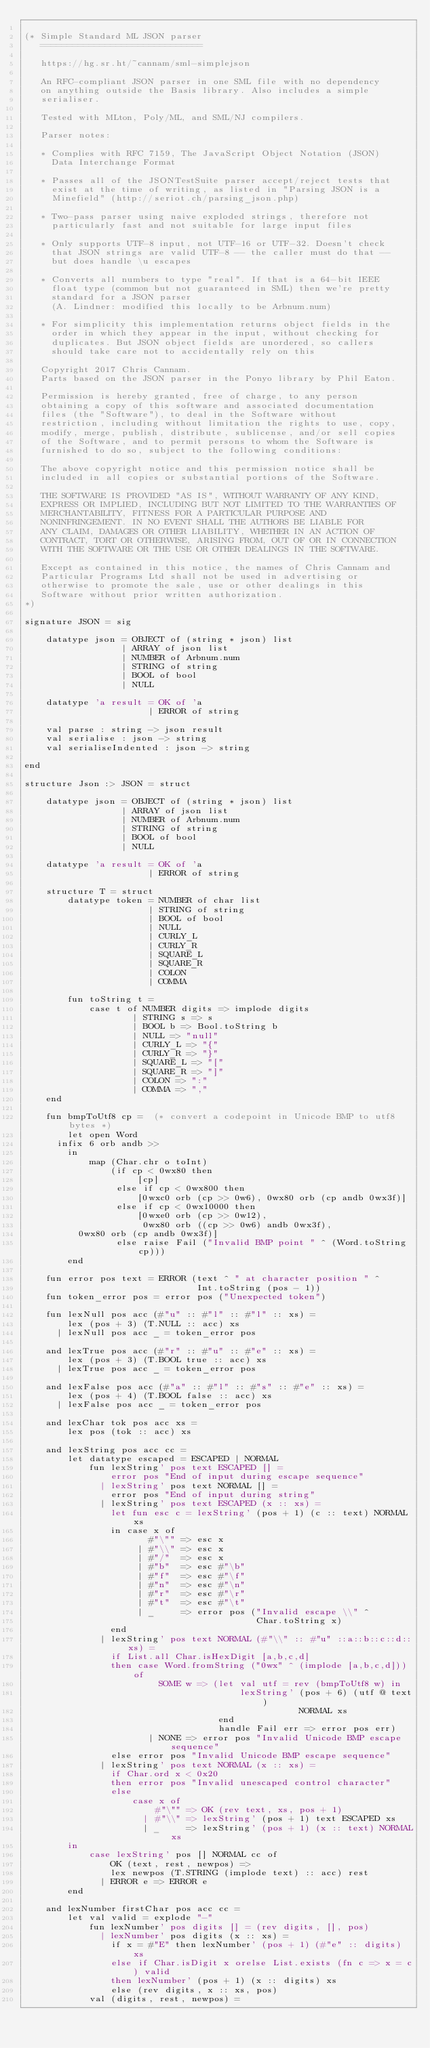<code> <loc_0><loc_0><loc_500><loc_500><_SML_>
(* Simple Standard ML JSON parser
   ==============================

   https://hg.sr.ht/~cannam/sml-simplejson

   An RFC-compliant JSON parser in one SML file with no dependency 
   on anything outside the Basis library. Also includes a simple
   serialiser.

   Tested with MLton, Poly/ML, and SML/NJ compilers.

   Parser notes:

   * Complies with RFC 7159, The JavaScript Object Notation (JSON)
     Data Interchange Format

   * Passes all of the JSONTestSuite parser accept/reject tests that
     exist at the time of writing, as listed in "Parsing JSON is a
     Minefield" (http://seriot.ch/parsing_json.php)
 
   * Two-pass parser using naive exploded strings, therefore not
     particularly fast and not suitable for large input files

   * Only supports UTF-8 input, not UTF-16 or UTF-32. Doesn't check
     that JSON strings are valid UTF-8 -- the caller must do that --
     but does handle \u escapes

   * Converts all numbers to type "real". If that is a 64-bit IEEE
     float type (common but not guaranteed in SML) then we're pretty
     standard for a JSON parser
     (A. Lindner: modified this locally to be Arbnum.num)

   * For simplicity this implementation returns object fields in the
     order in which they appear in the input, without checking for
     duplicates. But JSON object fields are unordered, so callers
     should take care not to accidentally rely on this

   Copyright 2017 Chris Cannam.
   Parts based on the JSON parser in the Ponyo library by Phil Eaton.

   Permission is hereby granted, free of charge, to any person
   obtaining a copy of this software and associated documentation
   files (the "Software"), to deal in the Software without
   restriction, including without limitation the rights to use, copy,
   modify, merge, publish, distribute, sublicense, and/or sell copies
   of the Software, and to permit persons to whom the Software is
   furnished to do so, subject to the following conditions:

   The above copyright notice and this permission notice shall be
   included in all copies or substantial portions of the Software.

   THE SOFTWARE IS PROVIDED "AS IS", WITHOUT WARRANTY OF ANY KIND,
   EXPRESS OR IMPLIED, INCLUDING BUT NOT LIMITED TO THE WARRANTIES OF
   MERCHANTABILITY, FITNESS FOR A PARTICULAR PURPOSE AND
   NONINFRINGEMENT. IN NO EVENT SHALL THE AUTHORS BE LIABLE FOR
   ANY CLAIM, DAMAGES OR OTHER LIABILITY, WHETHER IN AN ACTION OF
   CONTRACT, TORT OR OTHERWISE, ARISING FROM, OUT OF OR IN CONNECTION
   WITH THE SOFTWARE OR THE USE OR OTHER DEALINGS IN THE SOFTWARE.

   Except as contained in this notice, the names of Chris Cannam and
   Particular Programs Ltd shall not be used in advertising or
   otherwise to promote the sale, use or other dealings in this
   Software without prior written authorization.
*)

signature JSON = sig

    datatype json = OBJECT of (string * json) list
                  | ARRAY of json list
                  | NUMBER of Arbnum.num
                  | STRING of string
                  | BOOL of bool
                  | NULL

    datatype 'a result = OK of 'a
                       | ERROR of string

    val parse : string -> json result
    val serialise : json -> string
    val serialiseIndented : json -> string

end

structure Json :> JSON = struct

    datatype json = OBJECT of (string * json) list
                  | ARRAY of json list
                  | NUMBER of Arbnum.num
                  | STRING of string
                  | BOOL of bool
                  | NULL

    datatype 'a result = OK of 'a
                       | ERROR of string

    structure T = struct
        datatype token = NUMBER of char list
                       | STRING of string
                       | BOOL of bool
                       | NULL
                       | CURLY_L
                       | CURLY_R
                       | SQUARE_L
                       | SQUARE_R
                       | COLON
                       | COMMA

        fun toString t =
            case t of NUMBER digits => implode digits
                    | STRING s => s
                    | BOOL b => Bool.toString b
                    | NULL => "null"
                    | CURLY_L => "{"
                    | CURLY_R => "}"
                    | SQUARE_L => "["
                    | SQUARE_R => "]"
                    | COLON => ":"
                    | COMMA => ","
    end

    fun bmpToUtf8 cp =  (* convert a codepoint in Unicode BMP to utf8 bytes *)
        let open Word
	    infix 6 orb andb >>
        in
            map (Char.chr o toInt)
                (if cp < 0wx80 then
                     [cp]
                 else if cp < 0wx800 then
                     [0wxc0 orb (cp >> 0w6), 0wx80 orb (cp andb 0wx3f)]
                 else if cp < 0wx10000 then
                     [0wxe0 orb (cp >> 0w12),
                      0wx80 orb ((cp >> 0w6) andb 0wx3f),
		      0wx80 orb (cp andb 0wx3f)]
                 else raise Fail ("Invalid BMP point " ^ (Word.toString cp)))
        end
                      
    fun error pos text = ERROR (text ^ " at character position " ^
                                Int.toString (pos - 1))
    fun token_error pos = error pos ("Unexpected token")

    fun lexNull pos acc (#"u" :: #"l" :: #"l" :: xs) =
        lex (pos + 3) (T.NULL :: acc) xs
      | lexNull pos acc _ = token_error pos

    and lexTrue pos acc (#"r" :: #"u" :: #"e" :: xs) =
        lex (pos + 3) (T.BOOL true :: acc) xs
      | lexTrue pos acc _ = token_error pos

    and lexFalse pos acc (#"a" :: #"l" :: #"s" :: #"e" :: xs) =
        lex (pos + 4) (T.BOOL false :: acc) xs
      | lexFalse pos acc _ = token_error pos

    and lexChar tok pos acc xs =
        lex pos (tok :: acc) xs
        
    and lexString pos acc cc =
        let datatype escaped = ESCAPED | NORMAL
            fun lexString' pos text ESCAPED [] =
                error pos "End of input during escape sequence"
              | lexString' pos text NORMAL [] = 
                error pos "End of input during string"
              | lexString' pos text ESCAPED (x :: xs) =
                let fun esc c = lexString' (pos + 1) (c :: text) NORMAL xs
                in case x of
                       #"\"" => esc x
                     | #"\\" => esc x
                     | #"/"  => esc x
                     | #"b"  => esc #"\b"
                     | #"f"  => esc #"\f"
                     | #"n"  => esc #"\n"
                     | #"r"  => esc #"\r"
                     | #"t"  => esc #"\t"
                     | _     => error pos ("Invalid escape \\" ^
                                           Char.toString x)
                end
              | lexString' pos text NORMAL (#"\\" :: #"u" ::a::b::c::d:: xs) =
                if List.all Char.isHexDigit [a,b,c,d]
                then case Word.fromString ("0wx" ^ (implode [a,b,c,d])) of
                         SOME w => (let val utf = rev (bmpToUtf8 w) in
                                        lexString' (pos + 6) (utf @ text)
                                                   NORMAL xs
                                    end
                                    handle Fail err => error pos err)
                       | NONE => error pos "Invalid Unicode BMP escape sequence"
                else error pos "Invalid Unicode BMP escape sequence"
              | lexString' pos text NORMAL (x :: xs) =
                if Char.ord x < 0x20
                then error pos "Invalid unescaped control character"
                else
                    case x of
                        #"\"" => OK (rev text, xs, pos + 1)
                      | #"\\" => lexString' (pos + 1) text ESCAPED xs
                      | _     => lexString' (pos + 1) (x :: text) NORMAL xs
        in
            case lexString' pos [] NORMAL cc of
                OK (text, rest, newpos) =>
                lex newpos (T.STRING (implode text) :: acc) rest
              | ERROR e => ERROR e
        end

    and lexNumber firstChar pos acc cc =
        let val valid = explode "-"
            fun lexNumber' pos digits [] = (rev digits, [], pos)
              | lexNumber' pos digits (x :: xs) =
                if x = #"E" then lexNumber' (pos + 1) (#"e" :: digits) xs
                else if Char.isDigit x orelse List.exists (fn c => x = c) valid
                then lexNumber' (pos + 1) (x :: digits) xs
                else (rev digits, x :: xs, pos)
            val (digits, rest, newpos) =</code> 